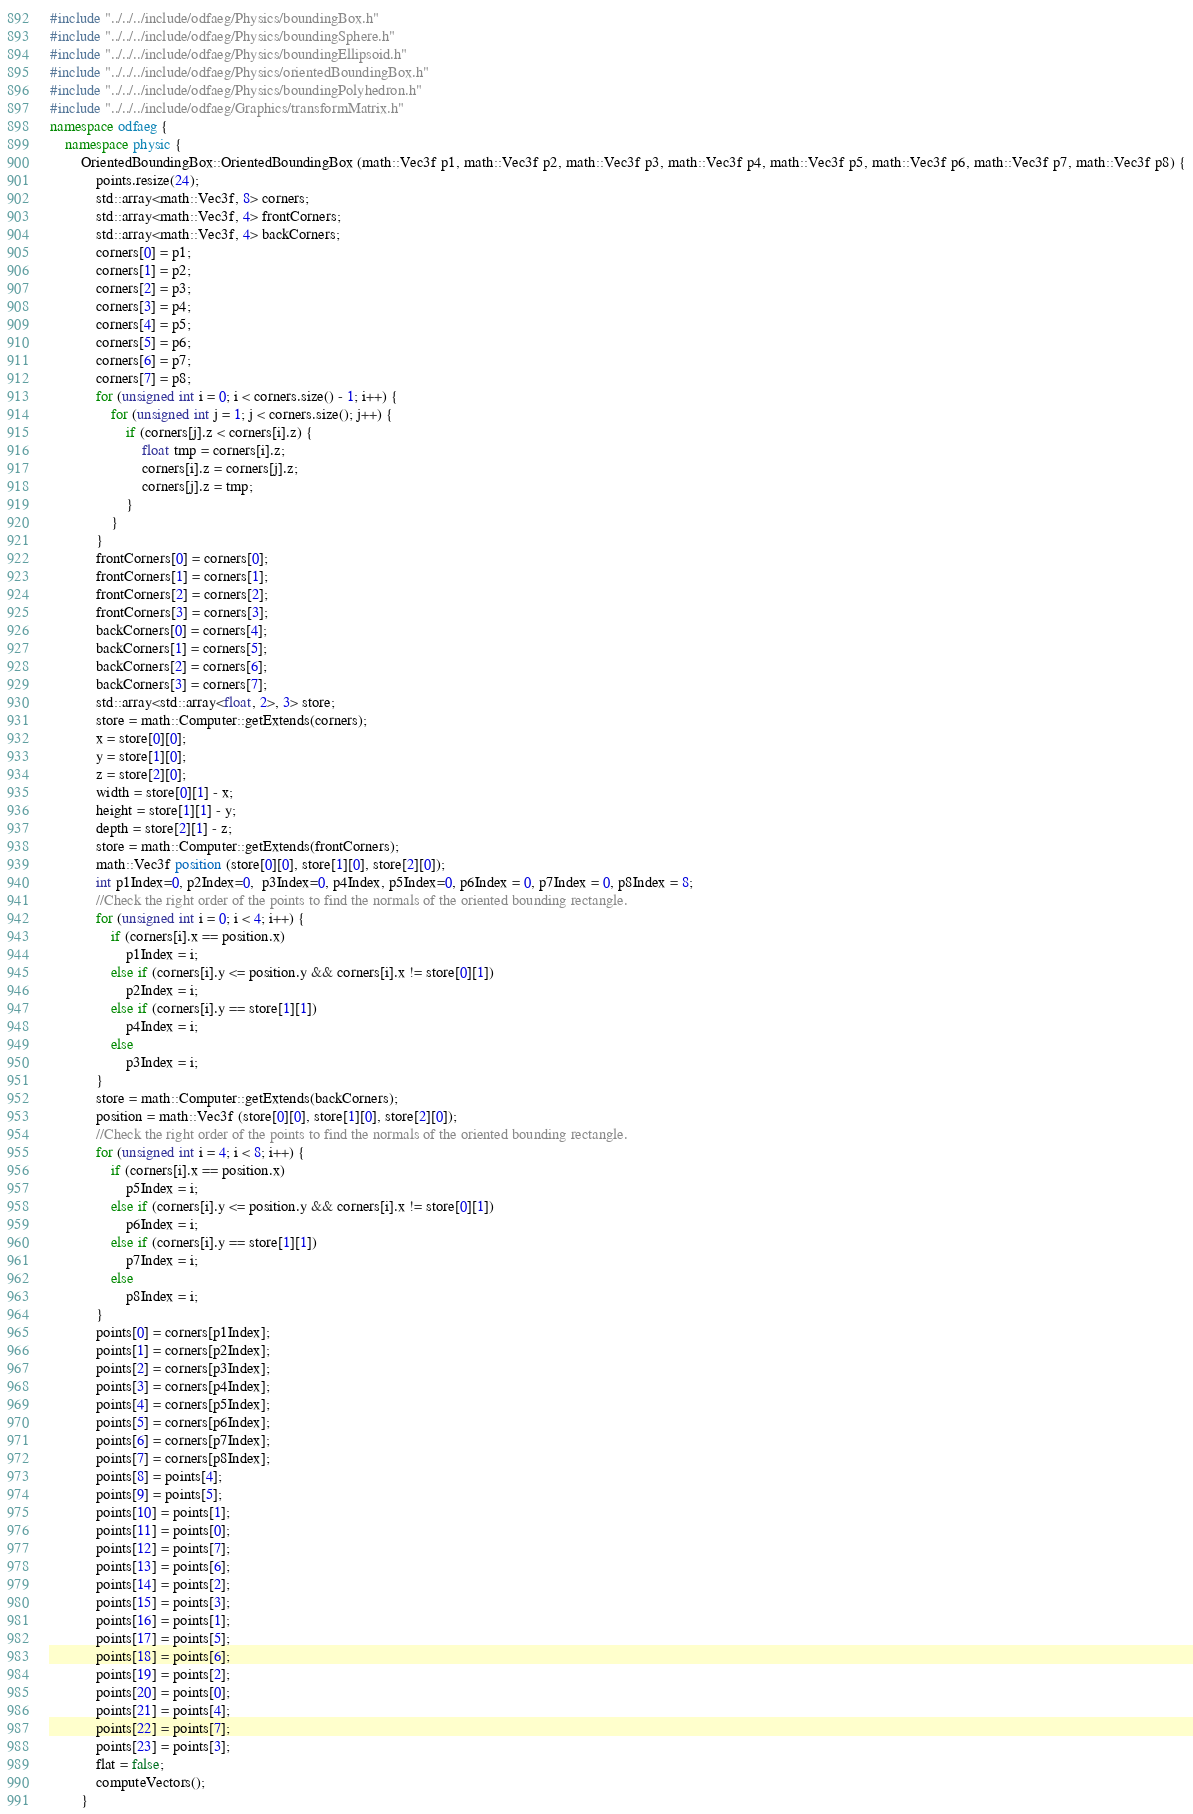Convert code to text. <code><loc_0><loc_0><loc_500><loc_500><_C++_>#include "../../../include/odfaeg/Physics/boundingBox.h"
#include "../../../include/odfaeg/Physics/boundingSphere.h"
#include "../../../include/odfaeg/Physics/boundingEllipsoid.h"
#include "../../../include/odfaeg/Physics/orientedBoundingBox.h"
#include "../../../include/odfaeg/Physics/boundingPolyhedron.h"
#include "../../../include/odfaeg/Graphics/transformMatrix.h"
namespace odfaeg {
    namespace physic {
        OrientedBoundingBox::OrientedBoundingBox (math::Vec3f p1, math::Vec3f p2, math::Vec3f p3, math::Vec3f p4, math::Vec3f p5, math::Vec3f p6, math::Vec3f p7, math::Vec3f p8) {
            points.resize(24);
            std::array<math::Vec3f, 8> corners;
            std::array<math::Vec3f, 4> frontCorners;
            std::array<math::Vec3f, 4> backCorners;
            corners[0] = p1;
            corners[1] = p2;
            corners[2] = p3;
            corners[3] = p4;
            corners[4] = p5;
            corners[5] = p6;
            corners[6] = p7;
            corners[7] = p8;
            for (unsigned int i = 0; i < corners.size() - 1; i++) {
                for (unsigned int j = 1; j < corners.size(); j++) {
                    if (corners[j].z < corners[i].z) {
                        float tmp = corners[i].z;
                        corners[i].z = corners[j].z;
                        corners[j].z = tmp;
                    }
                }
            }
            frontCorners[0] = corners[0];
            frontCorners[1] = corners[1];
            frontCorners[2] = corners[2];
            frontCorners[3] = corners[3];
            backCorners[0] = corners[4];
            backCorners[1] = corners[5];
            backCorners[2] = corners[6];
            backCorners[3] = corners[7];
            std::array<std::array<float, 2>, 3> store;
            store = math::Computer::getExtends(corners);
            x = store[0][0];
            y = store[1][0];
            z = store[2][0];
            width = store[0][1] - x;
            height = store[1][1] - y;
            depth = store[2][1] - z;
            store = math::Computer::getExtends(frontCorners);
            math::Vec3f position (store[0][0], store[1][0], store[2][0]);
            int p1Index=0, p2Index=0,  p3Index=0, p4Index, p5Index=0, p6Index = 0, p7Index = 0, p8Index = 8;
            //Check the right order of the points to find the normals of the oriented bounding rectangle.
            for (unsigned int i = 0; i < 4; i++) {
                if (corners[i].x == position.x)
                    p1Index = i;
                else if (corners[i].y <= position.y && corners[i].x != store[0][1])
                    p2Index = i;
                else if (corners[i].y == store[1][1])
                    p4Index = i;
                else
                    p3Index = i;
            }
            store = math::Computer::getExtends(backCorners);
            position = math::Vec3f (store[0][0], store[1][0], store[2][0]);
            //Check the right order of the points to find the normals of the oriented bounding rectangle.
            for (unsigned int i = 4; i < 8; i++) {
                if (corners[i].x == position.x)
                    p5Index = i;
                else if (corners[i].y <= position.y && corners[i].x != store[0][1])
                    p6Index = i;
                else if (corners[i].y == store[1][1])
                    p7Index = i;
                else
                    p8Index = i;
            }
            points[0] = corners[p1Index];
            points[1] = corners[p2Index];
            points[2] = corners[p3Index];
            points[3] = corners[p4Index];
            points[4] = corners[p5Index];
            points[5] = corners[p6Index];
            points[6] = corners[p7Index];
            points[7] = corners[p8Index];
            points[8] = points[4];
            points[9] = points[5];
            points[10] = points[1];
            points[11] = points[0];
            points[12] = points[7];
            points[13] = points[6];
            points[14] = points[2];
            points[15] = points[3];
            points[16] = points[1];
            points[17] = points[5];
            points[18] = points[6];
            points[19] = points[2];
            points[20] = points[0];
            points[21] = points[4];
            points[22] = points[7];
            points[23] = points[3];
            flat = false;
            computeVectors();
        }</code> 